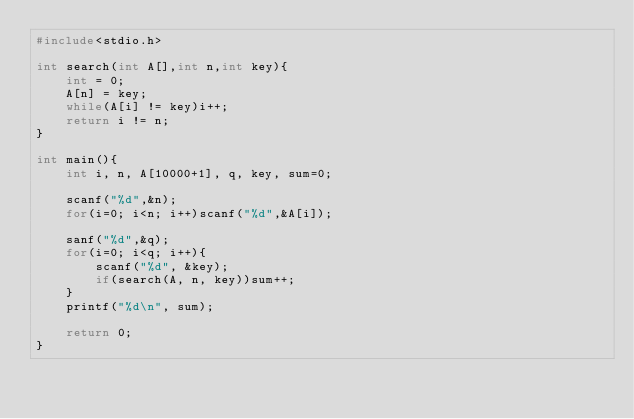<code> <loc_0><loc_0><loc_500><loc_500><_C_>#include<stdio.h>

int search(int A[],int n,int key){
	int = 0;
	A[n] = key;
	while(A[i] != key)i++;
	return i != n;
}

int main(){
	int i, n, A[10000+1], q, key, sum=0;
	
	scanf("%d",&n);
	for(i=0; i<n; i++)scanf("%d",&A[i]);
	
	sanf("%d",&q);
	for(i=0; i<q; i++){
		scanf("%d", &key);
		if(search(A, n, key))sum++;
	}
	printf("%d\n", sum);
	
	return 0;
}
		</code> 